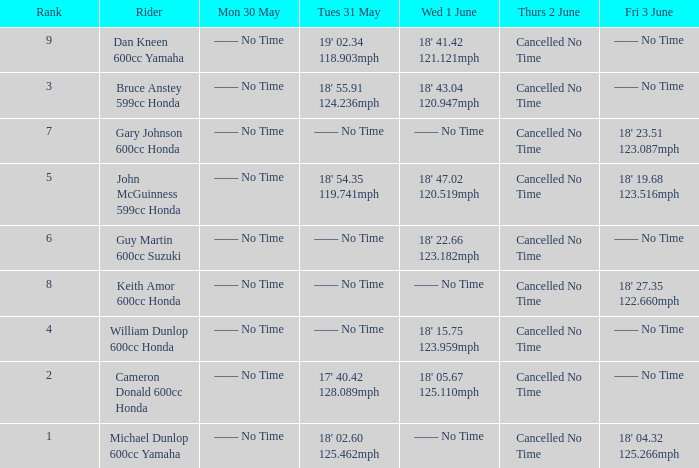What is the rank of the rider whose Tues 31 May time was 19' 02.34 118.903mph? 9.0. 